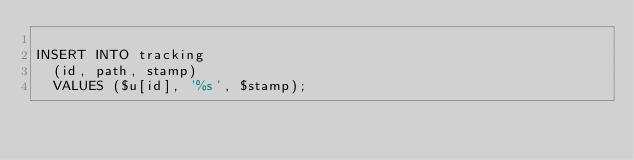<code> <loc_0><loc_0><loc_500><loc_500><_SQL_>
INSERT INTO tracking
  (id, path, stamp)
  VALUES ($u[id], '%s', $stamp);</code> 